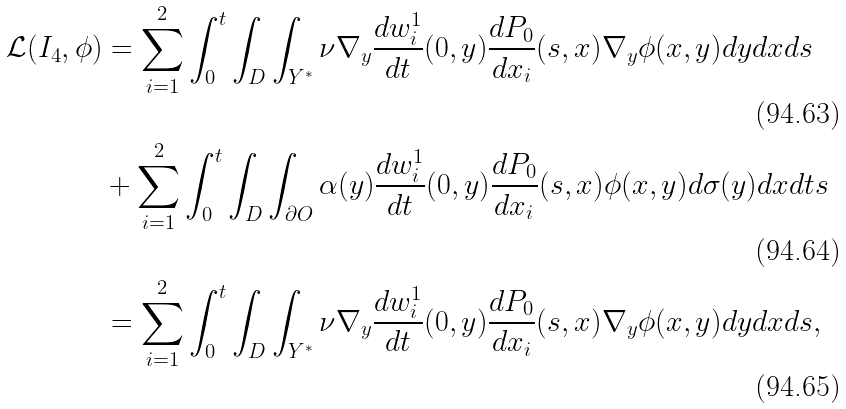<formula> <loc_0><loc_0><loc_500><loc_500>\mathcal { L } ( I _ { 4 } , \phi ) & = \sum _ { i = 1 } ^ { 2 } \int _ { 0 } ^ { t } \int _ { D } \int _ { Y ^ { * } } \nu \nabla _ { y } \frac { d w _ { i } ^ { 1 } } { d t } ( 0 , y ) \frac { d P _ { 0 } } { d x _ { i } } ( s , x ) \nabla _ { y } \phi ( x , y ) d y d x d s \\ & + \sum _ { i = 1 } ^ { 2 } \int _ { 0 } ^ { t } \int _ { D } \int _ { \partial O } \alpha ( y ) \frac { d w _ { i } ^ { 1 } } { d t } ( 0 , y ) \frac { d P _ { 0 } } { d x _ { i } } ( s , x ) \phi ( x , y ) d \sigma ( y ) d x d t s \\ & = \sum _ { i = 1 } ^ { 2 } \int _ { 0 } ^ { t } \int _ { D } \int _ { Y ^ { * } } \nu \nabla _ { y } \frac { d w _ { i } ^ { 1 } } { d t } ( 0 , y ) \frac { d P _ { 0 } } { d x _ { i } } ( s , x ) \nabla _ { y } \phi ( x , y ) d y d x d s ,</formula> 